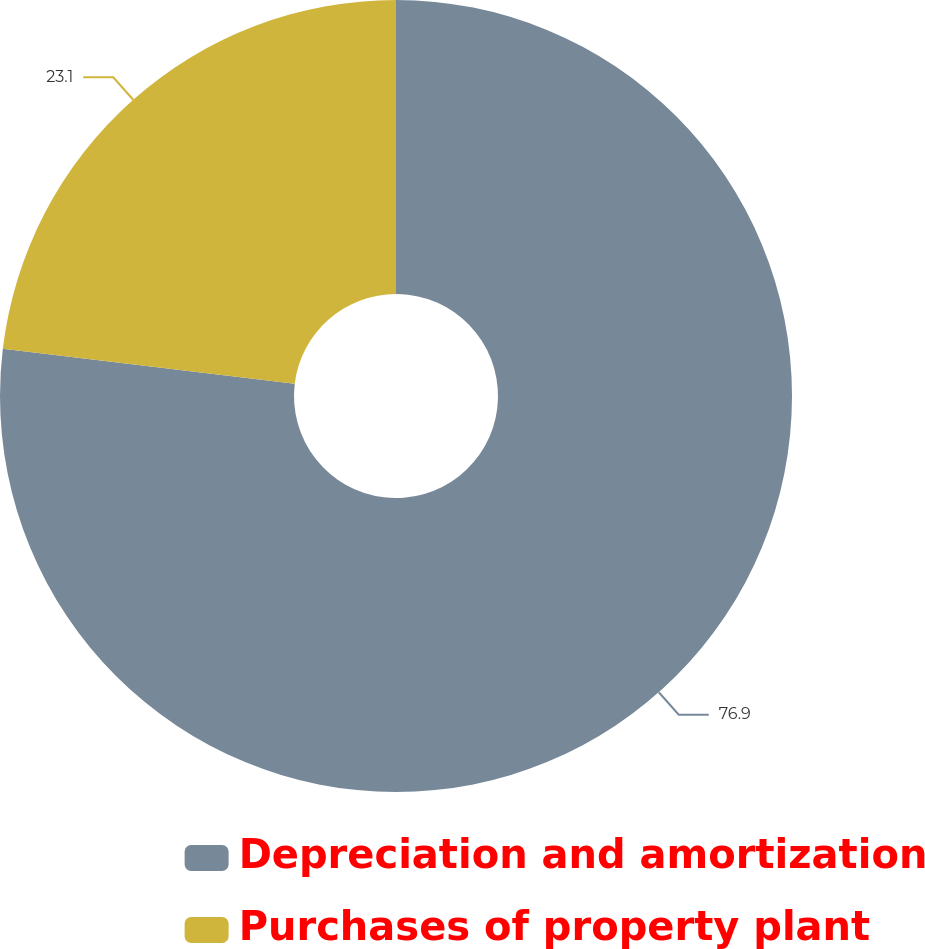Convert chart to OTSL. <chart><loc_0><loc_0><loc_500><loc_500><pie_chart><fcel>Depreciation and amortization<fcel>Purchases of property plant<nl><fcel>76.9%<fcel>23.1%<nl></chart> 